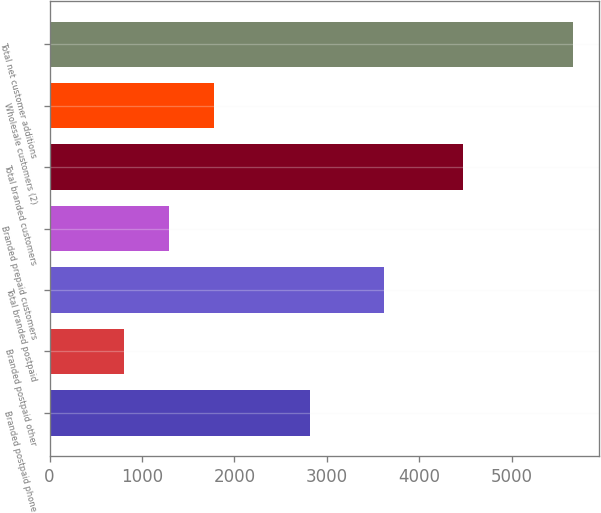Convert chart to OTSL. <chart><loc_0><loc_0><loc_500><loc_500><bar_chart><fcel>Branded postpaid phone<fcel>Branded postpaid other<fcel>Total branded postpaid<fcel>Branded prepaid customers<fcel>Total branded customers<fcel>Wholesale customers (2)<fcel>Total net customer additions<nl><fcel>2817<fcel>803<fcel>3620<fcel>1288.5<fcel>4475<fcel>1774<fcel>5658<nl></chart> 